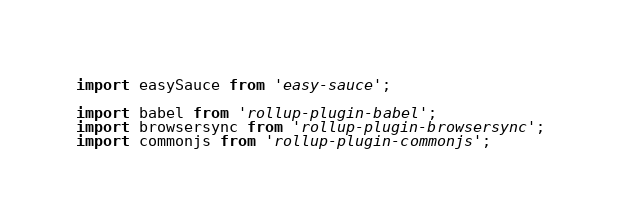Convert code to text. <code><loc_0><loc_0><loc_500><loc_500><_JavaScript_>import easySauce from 'easy-sauce';

import babel from 'rollup-plugin-babel';
import browsersync from 'rollup-plugin-browsersync';
import commonjs from 'rollup-plugin-commonjs';</code> 